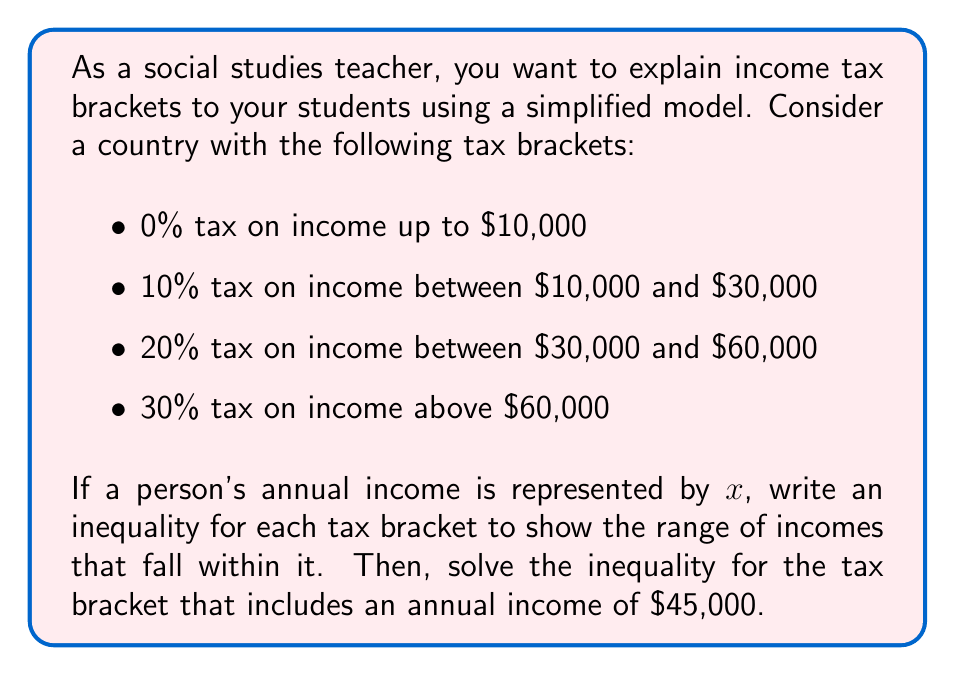Could you help me with this problem? Let's break this down step-by-step:

1. First, we'll write inequalities for each tax bracket:

   - 0% bracket: $0 \leq x \leq 10000$
   - 10% bracket: $10000 < x \leq 30000$
   - 20% bracket: $30000 < x \leq 60000$
   - 30% bracket: $x > 60000$

2. Now, we need to determine which bracket includes an annual income of $45,000. We can see that it falls within the 20% bracket.

3. Let's focus on solving the inequality for the 20% bracket:

   $30000 < x \leq 60000$

4. This compound inequality can be split into two parts:

   $x > 30000$ and $x \leq 60000$

5. We already know that $45000$ satisfies both parts of this inequality, but let's verify:

   For $x > 30000$: $45000 > 30000$ (True)
   For $x \leq 60000$: $45000 \leq 60000$ (True)

6. Therefore, $45000$ is indeed within this tax bracket.

This simplified model helps students understand how tax brackets work and how to represent them mathematically using inequalities.
Answer: The inequality representing the tax bracket for an annual income of $45,000 is:

$30000 < x \leq 60000$

where $x$ represents the annual income. 